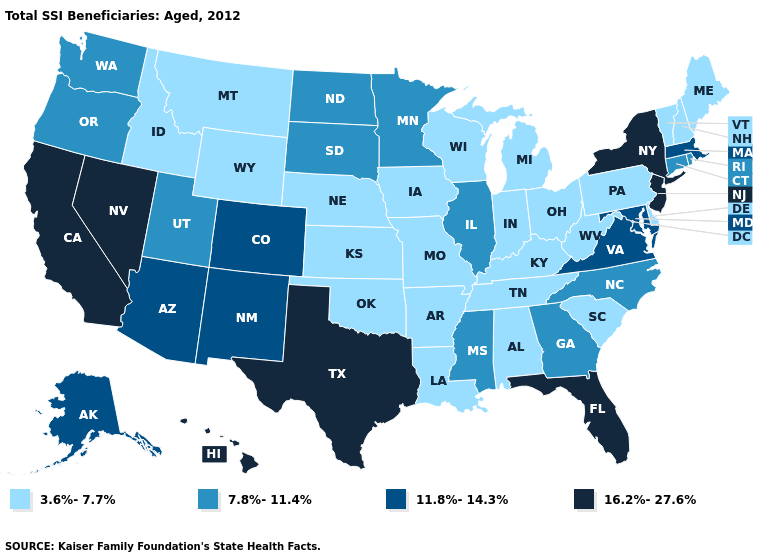Which states have the highest value in the USA?
Be succinct. California, Florida, Hawaii, Nevada, New Jersey, New York, Texas. Name the states that have a value in the range 7.8%-11.4%?
Keep it brief. Connecticut, Georgia, Illinois, Minnesota, Mississippi, North Carolina, North Dakota, Oregon, Rhode Island, South Dakota, Utah, Washington. Does the first symbol in the legend represent the smallest category?
Quick response, please. Yes. Among the states that border Kansas , which have the lowest value?
Write a very short answer. Missouri, Nebraska, Oklahoma. Which states have the highest value in the USA?
Keep it brief. California, Florida, Hawaii, Nevada, New Jersey, New York, Texas. Does Kentucky have the highest value in the USA?
Keep it brief. No. Name the states that have a value in the range 7.8%-11.4%?
Give a very brief answer. Connecticut, Georgia, Illinois, Minnesota, Mississippi, North Carolina, North Dakota, Oregon, Rhode Island, South Dakota, Utah, Washington. Which states have the lowest value in the South?
Quick response, please. Alabama, Arkansas, Delaware, Kentucky, Louisiana, Oklahoma, South Carolina, Tennessee, West Virginia. What is the value of Delaware?
Give a very brief answer. 3.6%-7.7%. Name the states that have a value in the range 11.8%-14.3%?
Short answer required. Alaska, Arizona, Colorado, Maryland, Massachusetts, New Mexico, Virginia. Which states have the lowest value in the USA?
Write a very short answer. Alabama, Arkansas, Delaware, Idaho, Indiana, Iowa, Kansas, Kentucky, Louisiana, Maine, Michigan, Missouri, Montana, Nebraska, New Hampshire, Ohio, Oklahoma, Pennsylvania, South Carolina, Tennessee, Vermont, West Virginia, Wisconsin, Wyoming. Does Missouri have the highest value in the USA?
Short answer required. No. Name the states that have a value in the range 11.8%-14.3%?
Short answer required. Alaska, Arizona, Colorado, Maryland, Massachusetts, New Mexico, Virginia. Does the map have missing data?
Concise answer only. No. 